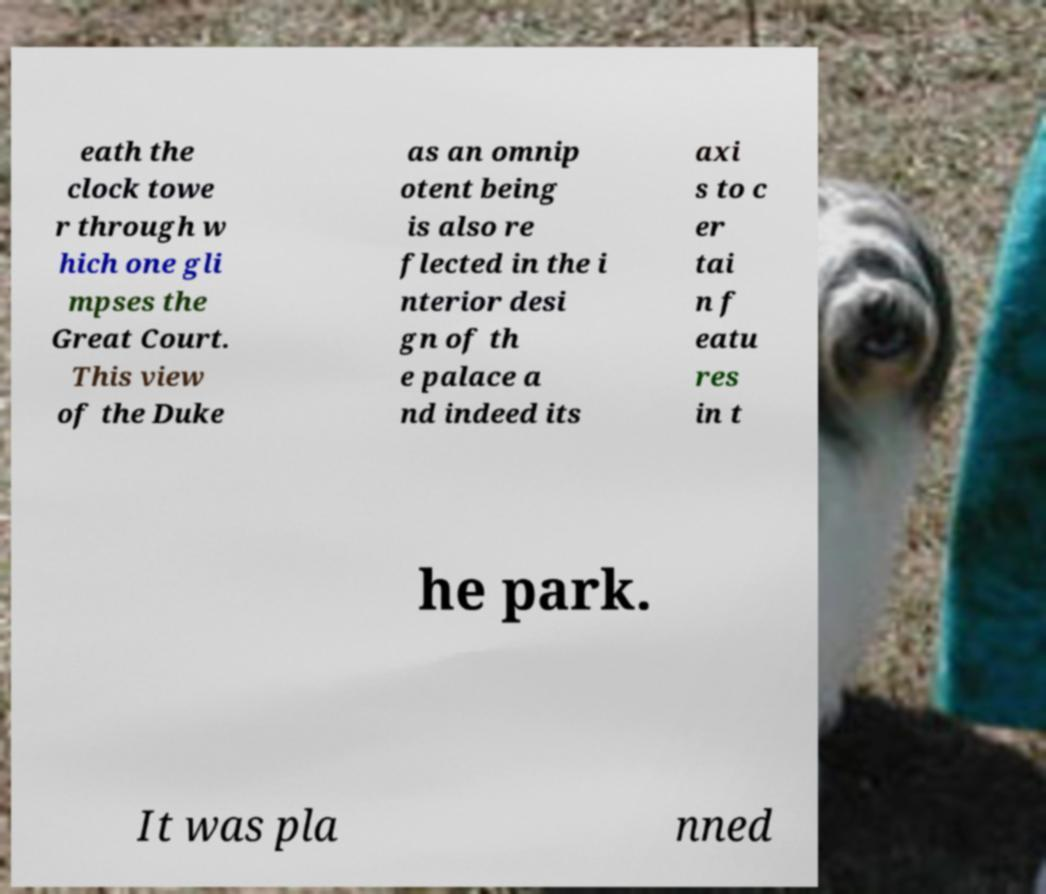For documentation purposes, I need the text within this image transcribed. Could you provide that? eath the clock towe r through w hich one gli mpses the Great Court. This view of the Duke as an omnip otent being is also re flected in the i nterior desi gn of th e palace a nd indeed its axi s to c er tai n f eatu res in t he park. It was pla nned 